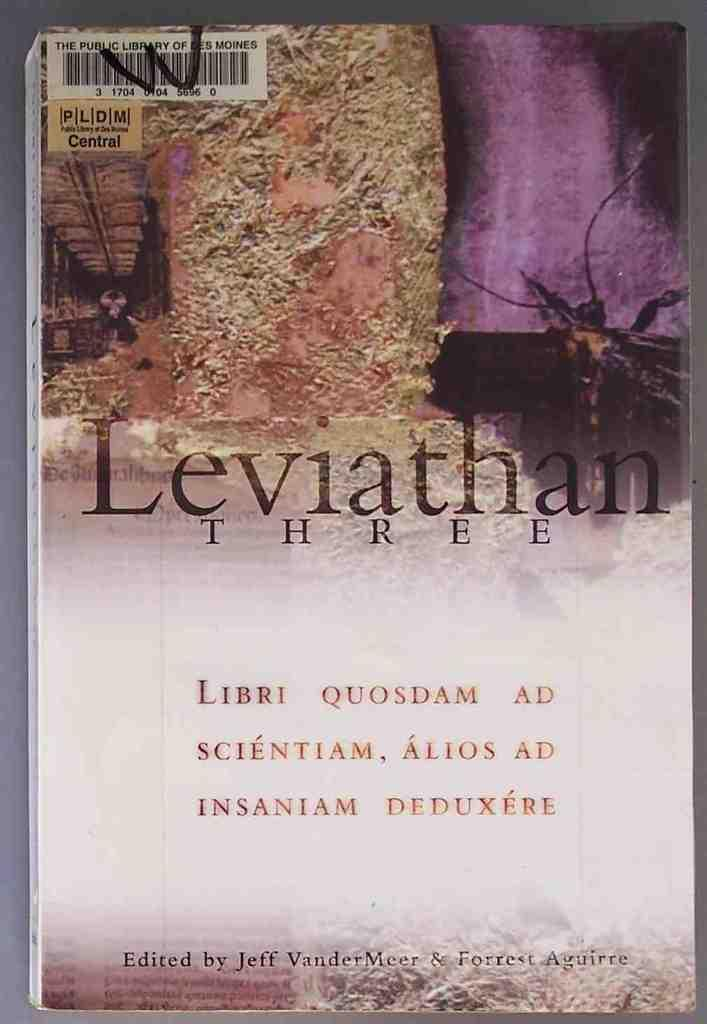<image>
Offer a succinct explanation of the picture presented. A book with the title Leviathan on it 